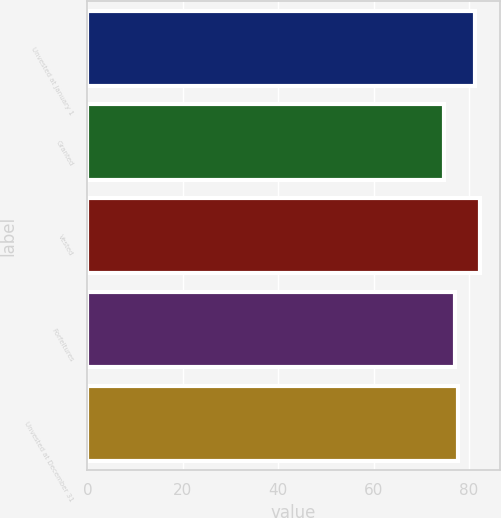Convert chart. <chart><loc_0><loc_0><loc_500><loc_500><bar_chart><fcel>Unvested at January 1<fcel>Granted<fcel>Vested<fcel>Forfeitures<fcel>Unvested at December 31<nl><fcel>81.19<fcel>74.82<fcel>82.35<fcel>77<fcel>77.75<nl></chart> 